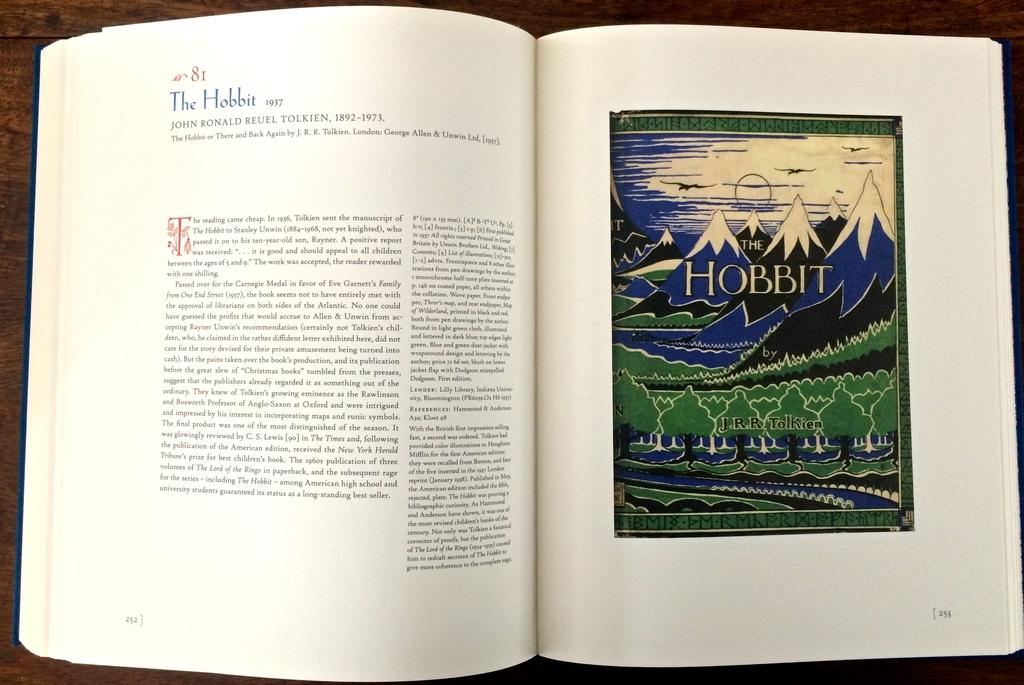<image>
Write a terse but informative summary of the picture. A book is open to an illustration reading The Hobbit by J.R.R. Tolkien. 